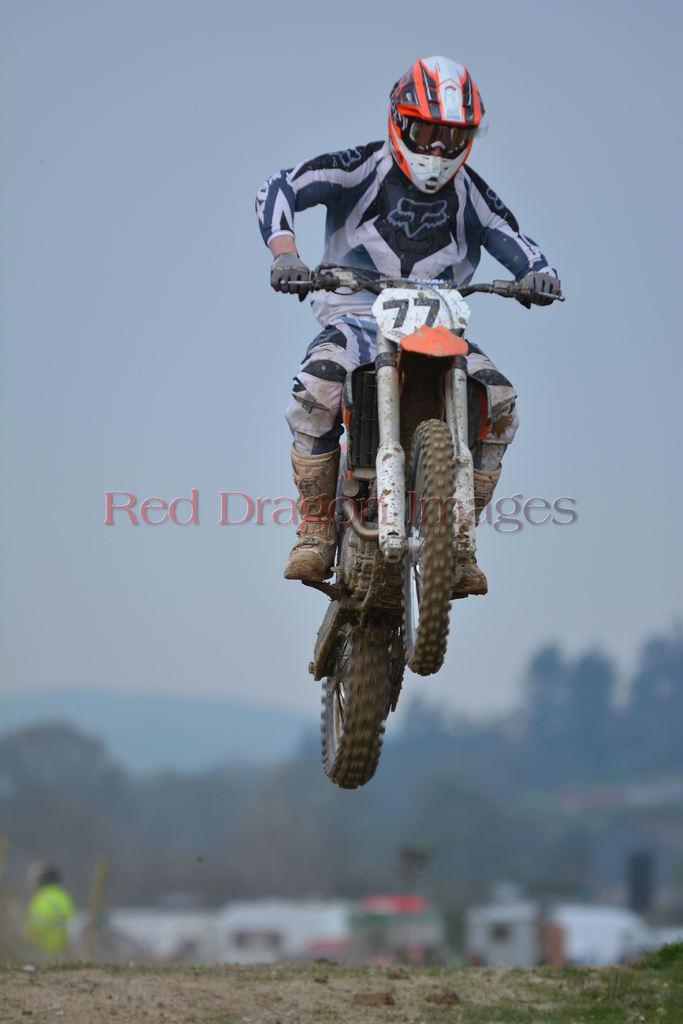How would you summarize this image in a sentence or two? In the center of the image we can see the text and a person in the air and wearing a helmet, sports dress, gloves, boots and driving a motorcycle. At the bottom of the image we can see the trees, buildings, grass, sand and a person is standing. In the background of the image we can see the sky. 